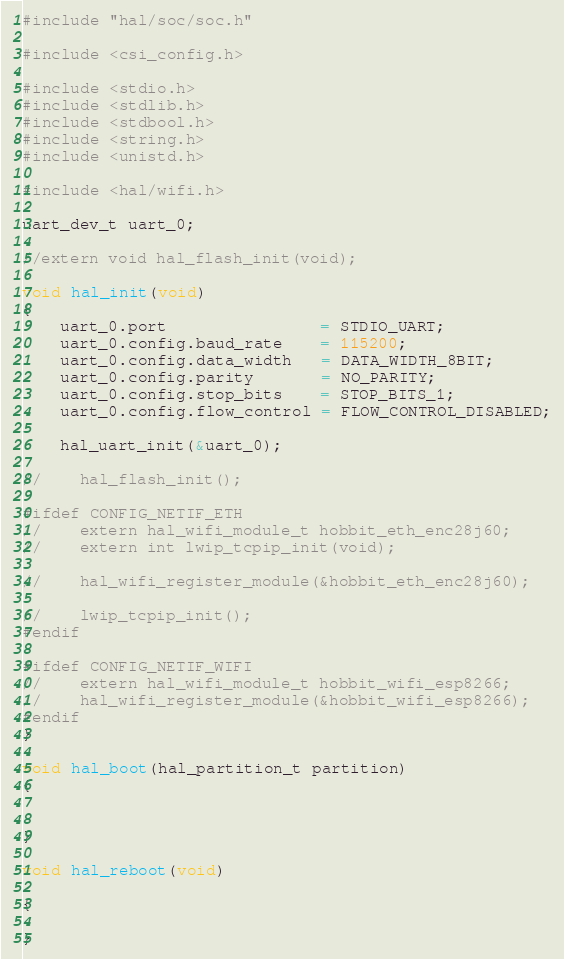<code> <loc_0><loc_0><loc_500><loc_500><_C_>#include "hal/soc/soc.h"

#include <csi_config.h>

#include <stdio.h>
#include <stdlib.h>
#include <stdbool.h>
#include <string.h>
#include <unistd.h>

#include <hal/wifi.h>

uart_dev_t uart_0;

//extern void hal_flash_init(void);

void hal_init(void)
{
    uart_0.port                = STDIO_UART;
    uart_0.config.baud_rate    = 115200;
    uart_0.config.data_width   = DATA_WIDTH_8BIT;
    uart_0.config.parity       = NO_PARITY;
    uart_0.config.stop_bits    = STOP_BITS_1;
    uart_0.config.flow_control = FLOW_CONTROL_DISABLED;

    hal_uart_init(&uart_0);

//    hal_flash_init();

#ifdef CONFIG_NETIF_ETH
//    extern hal_wifi_module_t hobbit_eth_enc28j60;
//    extern int lwip_tcpip_init(void);

//    hal_wifi_register_module(&hobbit_eth_enc28j60);

//    lwip_tcpip_init();
#endif

#ifdef CONFIG_NETIF_WIFI
//    extern hal_wifi_module_t hobbit_wifi_esp8266;
//    hal_wifi_register_module(&hobbit_wifi_esp8266);
#endif
}

void hal_boot(hal_partition_t partition)
{


}

void hal_reboot(void)

{

}

</code> 